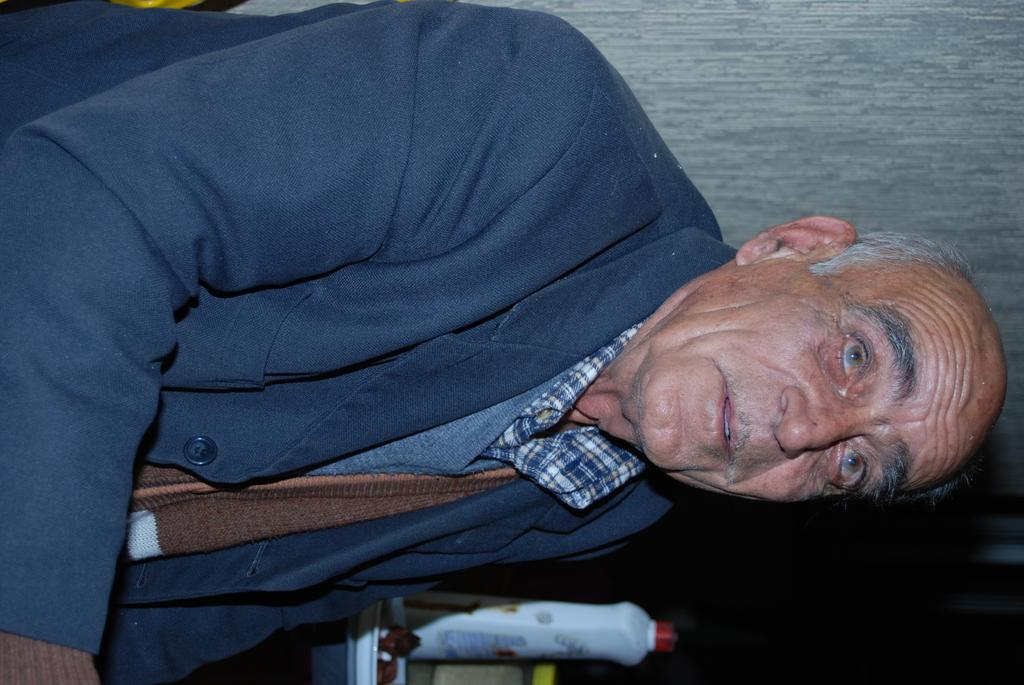Who is present in the image? There is a man in the image. What is the man wearing? The man is wearing a blue jacket. What object can be seen in the image besides the man? There is a bottle in the image. What type of destruction can be seen happening in the image? There is no destruction present in the image; it features a man wearing a blue jacket and a bottle. 